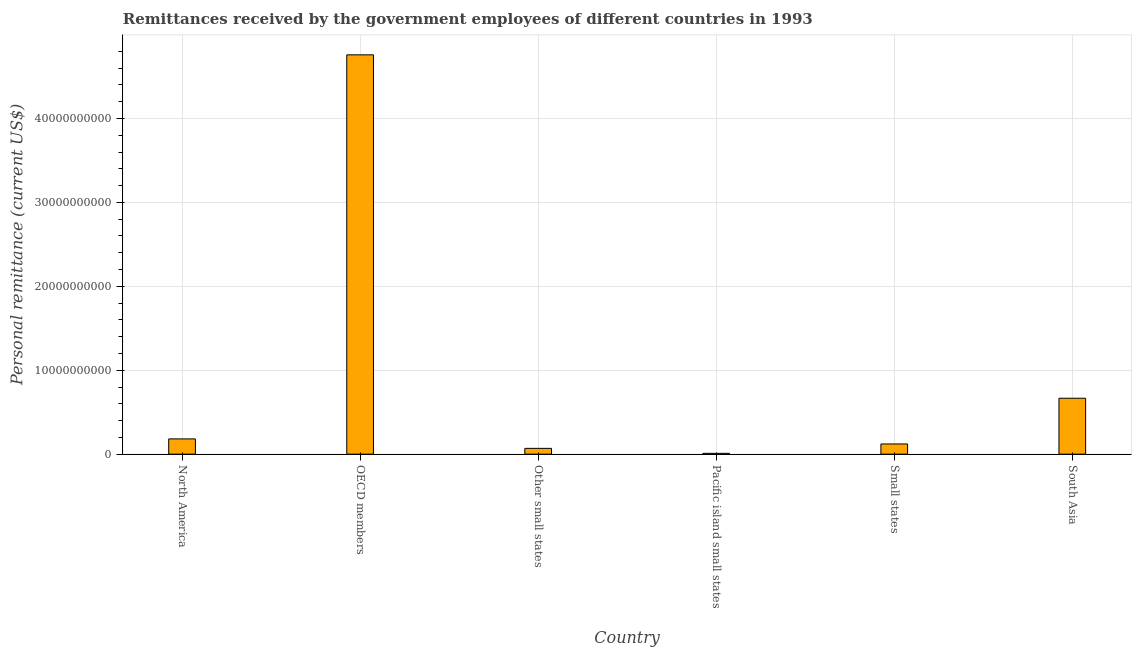What is the title of the graph?
Offer a terse response. Remittances received by the government employees of different countries in 1993. What is the label or title of the Y-axis?
Your response must be concise. Personal remittance (current US$). What is the personal remittances in OECD members?
Keep it short and to the point. 4.76e+1. Across all countries, what is the maximum personal remittances?
Keep it short and to the point. 4.76e+1. Across all countries, what is the minimum personal remittances?
Ensure brevity in your answer.  9.72e+07. In which country was the personal remittances minimum?
Provide a succinct answer. Pacific island small states. What is the sum of the personal remittances?
Your answer should be very brief. 5.81e+1. What is the difference between the personal remittances in Small states and South Asia?
Provide a succinct answer. -5.45e+09. What is the average personal remittances per country?
Make the answer very short. 9.68e+09. What is the median personal remittances?
Your answer should be compact. 1.52e+09. In how many countries, is the personal remittances greater than 2000000000 US$?
Your answer should be compact. 2. What is the ratio of the personal remittances in Pacific island small states to that in South Asia?
Offer a terse response. 0.01. Is the personal remittances in North America less than that in South Asia?
Offer a very short reply. Yes. Is the difference between the personal remittances in Small states and South Asia greater than the difference between any two countries?
Make the answer very short. No. What is the difference between the highest and the second highest personal remittances?
Keep it short and to the point. 4.09e+1. Is the sum of the personal remittances in Pacific island small states and Small states greater than the maximum personal remittances across all countries?
Ensure brevity in your answer.  No. What is the difference between the highest and the lowest personal remittances?
Provide a short and direct response. 4.75e+1. How many countries are there in the graph?
Give a very brief answer. 6. What is the difference between two consecutive major ticks on the Y-axis?
Offer a very short reply. 1.00e+1. Are the values on the major ticks of Y-axis written in scientific E-notation?
Keep it short and to the point. No. What is the Personal remittance (current US$) of North America?
Your answer should be very brief. 1.82e+09. What is the Personal remittance (current US$) of OECD members?
Your answer should be very brief. 4.76e+1. What is the Personal remittance (current US$) of Other small states?
Give a very brief answer. 6.91e+08. What is the Personal remittance (current US$) of Pacific island small states?
Your response must be concise. 9.72e+07. What is the Personal remittance (current US$) of Small states?
Your answer should be very brief. 1.22e+09. What is the Personal remittance (current US$) of South Asia?
Make the answer very short. 6.66e+09. What is the difference between the Personal remittance (current US$) in North America and OECD members?
Your answer should be very brief. -4.58e+1. What is the difference between the Personal remittance (current US$) in North America and Other small states?
Give a very brief answer. 1.13e+09. What is the difference between the Personal remittance (current US$) in North America and Pacific island small states?
Your response must be concise. 1.72e+09. What is the difference between the Personal remittance (current US$) in North America and Small states?
Make the answer very short. 6.05e+08. What is the difference between the Personal remittance (current US$) in North America and South Asia?
Keep it short and to the point. -4.84e+09. What is the difference between the Personal remittance (current US$) in OECD members and Other small states?
Your answer should be compact. 4.69e+1. What is the difference between the Personal remittance (current US$) in OECD members and Pacific island small states?
Your answer should be compact. 4.75e+1. What is the difference between the Personal remittance (current US$) in OECD members and Small states?
Provide a succinct answer. 4.64e+1. What is the difference between the Personal remittance (current US$) in OECD members and South Asia?
Your answer should be very brief. 4.09e+1. What is the difference between the Personal remittance (current US$) in Other small states and Pacific island small states?
Give a very brief answer. 5.94e+08. What is the difference between the Personal remittance (current US$) in Other small states and Small states?
Keep it short and to the point. -5.24e+08. What is the difference between the Personal remittance (current US$) in Other small states and South Asia?
Offer a terse response. -5.97e+09. What is the difference between the Personal remittance (current US$) in Pacific island small states and Small states?
Your response must be concise. -1.12e+09. What is the difference between the Personal remittance (current US$) in Pacific island small states and South Asia?
Give a very brief answer. -6.57e+09. What is the difference between the Personal remittance (current US$) in Small states and South Asia?
Your response must be concise. -5.45e+09. What is the ratio of the Personal remittance (current US$) in North America to that in OECD members?
Provide a succinct answer. 0.04. What is the ratio of the Personal remittance (current US$) in North America to that in Other small states?
Your answer should be very brief. 2.63. What is the ratio of the Personal remittance (current US$) in North America to that in Pacific island small states?
Offer a very short reply. 18.71. What is the ratio of the Personal remittance (current US$) in North America to that in Small states?
Your response must be concise. 1.5. What is the ratio of the Personal remittance (current US$) in North America to that in South Asia?
Give a very brief answer. 0.27. What is the ratio of the Personal remittance (current US$) in OECD members to that in Other small states?
Provide a short and direct response. 68.88. What is the ratio of the Personal remittance (current US$) in OECD members to that in Pacific island small states?
Make the answer very short. 489.35. What is the ratio of the Personal remittance (current US$) in OECD members to that in Small states?
Provide a short and direct response. 39.16. What is the ratio of the Personal remittance (current US$) in OECD members to that in South Asia?
Ensure brevity in your answer.  7.14. What is the ratio of the Personal remittance (current US$) in Other small states to that in Pacific island small states?
Make the answer very short. 7.11. What is the ratio of the Personal remittance (current US$) in Other small states to that in Small states?
Offer a very short reply. 0.57. What is the ratio of the Personal remittance (current US$) in Other small states to that in South Asia?
Offer a very short reply. 0.1. What is the ratio of the Personal remittance (current US$) in Pacific island small states to that in Small states?
Your answer should be very brief. 0.08. What is the ratio of the Personal remittance (current US$) in Pacific island small states to that in South Asia?
Offer a very short reply. 0.01. What is the ratio of the Personal remittance (current US$) in Small states to that in South Asia?
Offer a terse response. 0.18. 